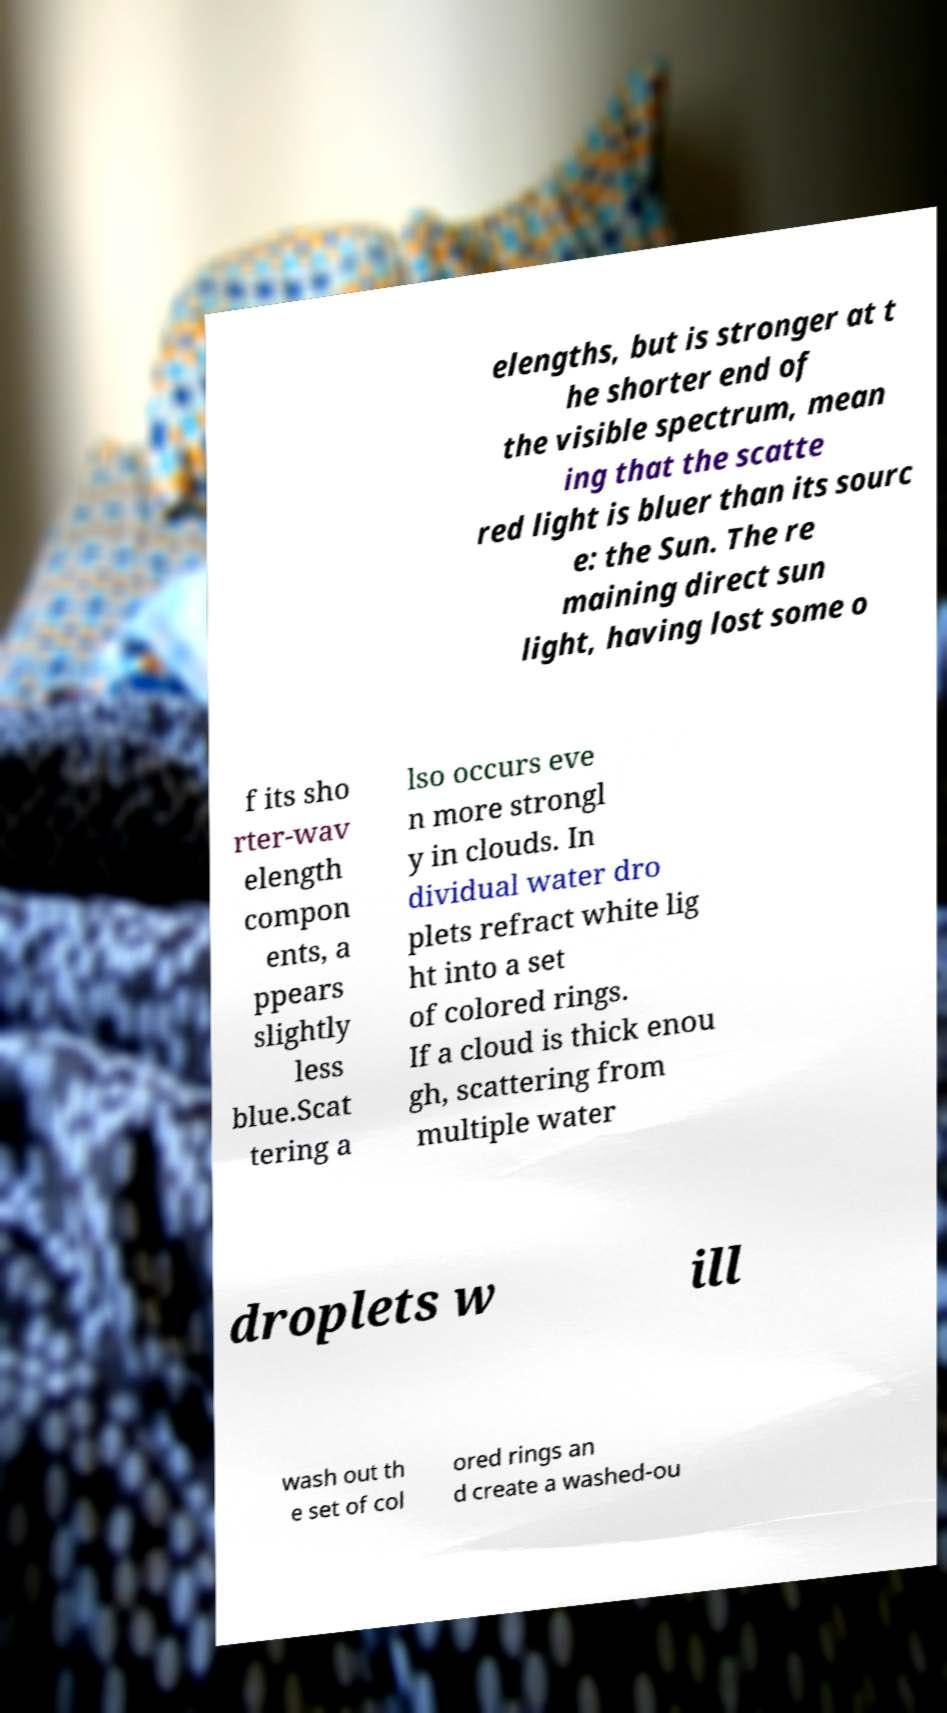Could you assist in decoding the text presented in this image and type it out clearly? elengths, but is stronger at t he shorter end of the visible spectrum, mean ing that the scatte red light is bluer than its sourc e: the Sun. The re maining direct sun light, having lost some o f its sho rter-wav elength compon ents, a ppears slightly less blue.Scat tering a lso occurs eve n more strongl y in clouds. In dividual water dro plets refract white lig ht into a set of colored rings. If a cloud is thick enou gh, scattering from multiple water droplets w ill wash out th e set of col ored rings an d create a washed-ou 